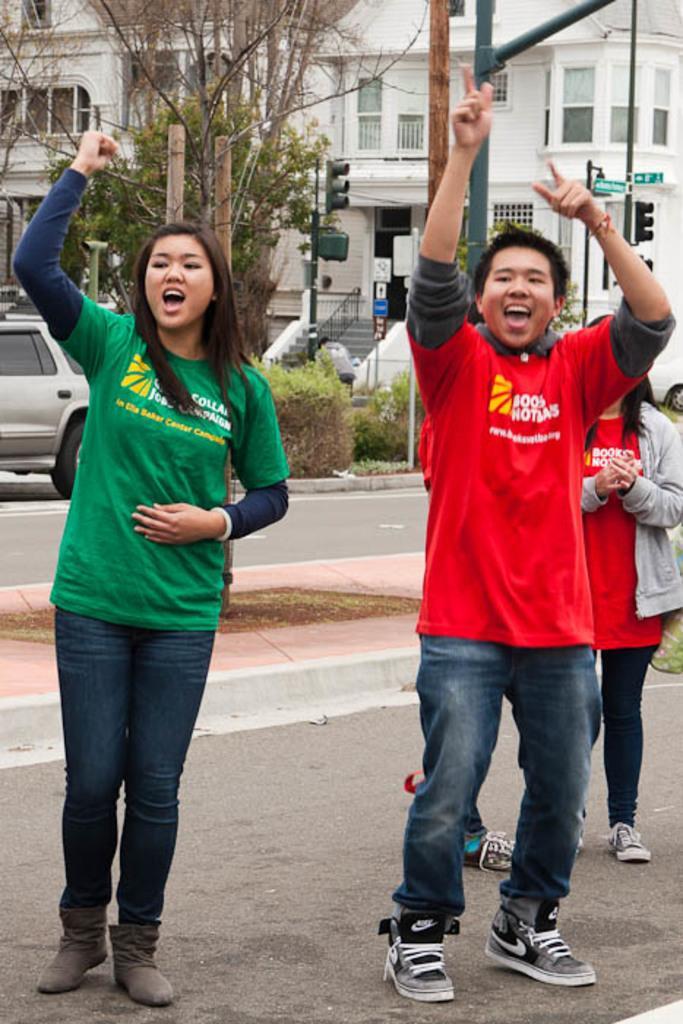Can you describe this image briefly? Here we can see a woman and a man are standing and shouting. In the background we can see two persons are standing on the ground,vehicle on the road,tree,poles,traffic signal pole,steps,fence,building,windows and other objects. 